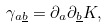Convert formula to latex. <formula><loc_0><loc_0><loc_500><loc_500>\gamma _ { a \underline { b } } = \partial _ { a } \partial _ { \underline { b } } K ,</formula> 